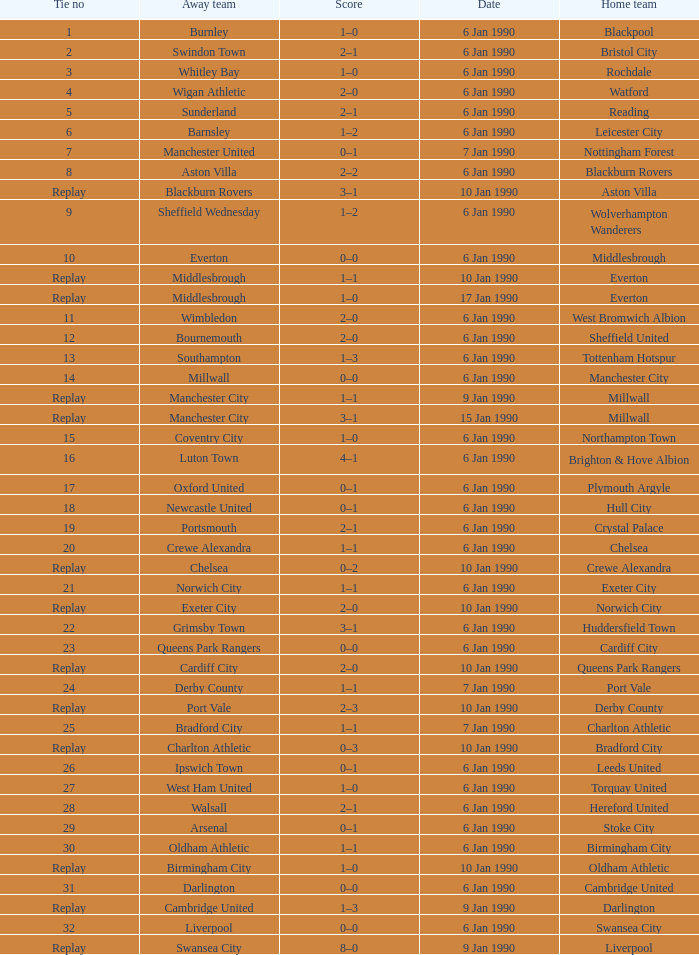What was the score of the game against away team crewe alexandra? 1–1. 